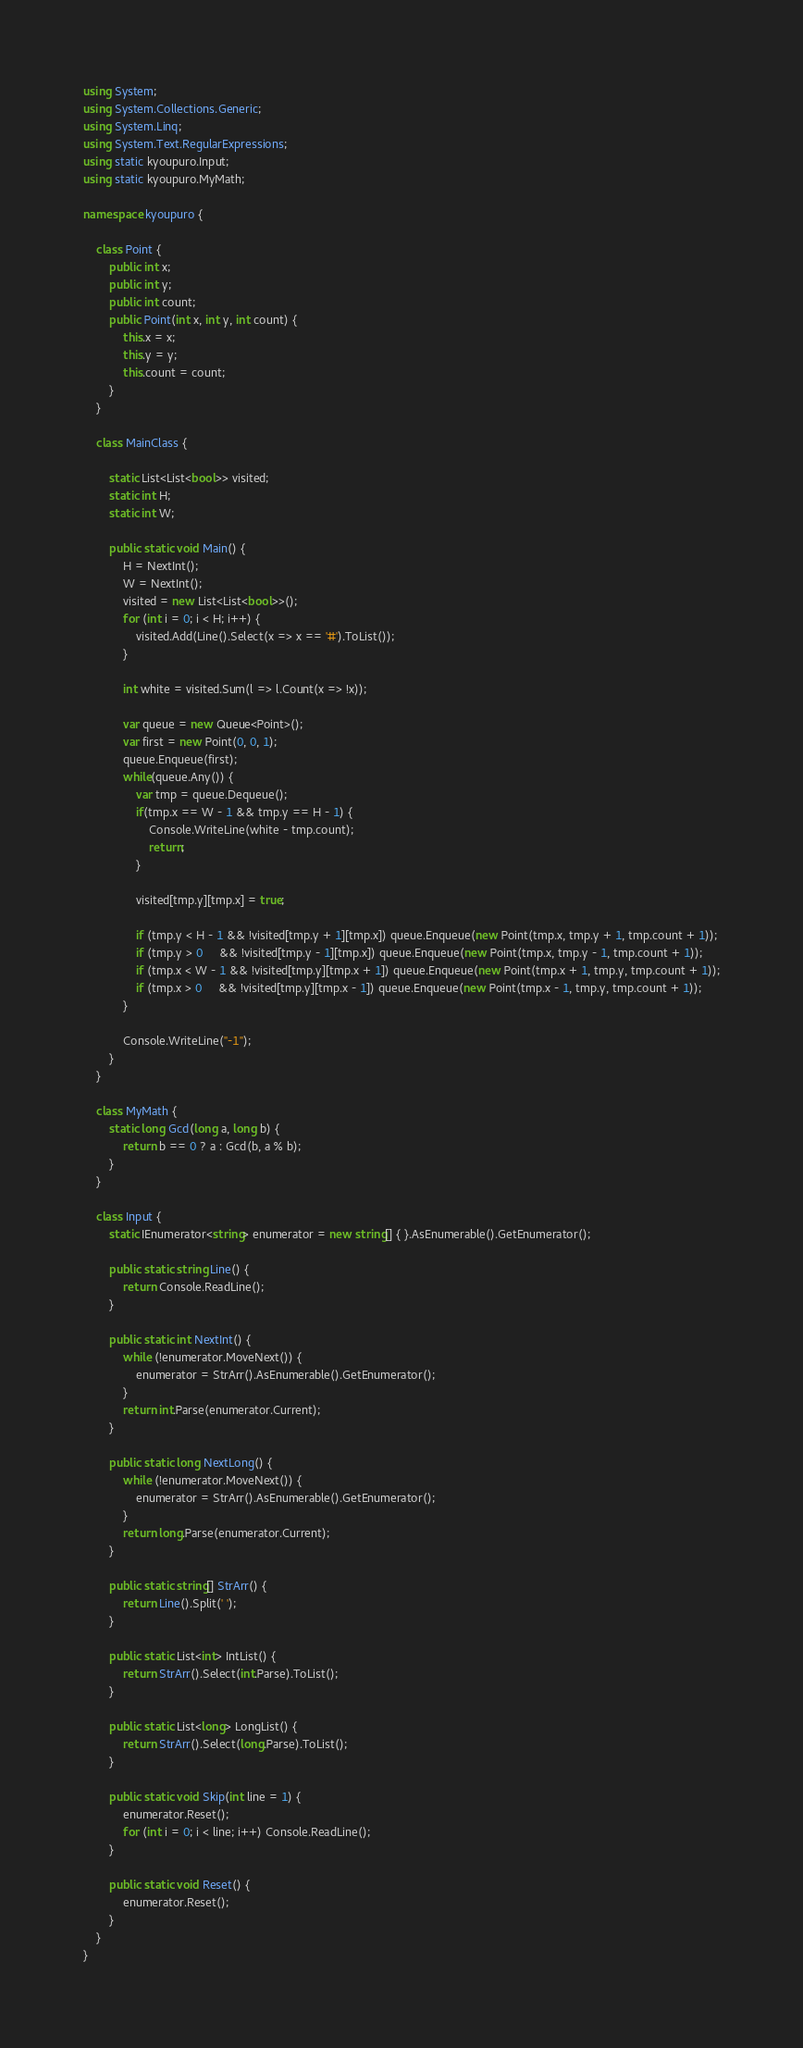<code> <loc_0><loc_0><loc_500><loc_500><_C#_>using System;
using System.Collections.Generic;
using System.Linq;
using System.Text.RegularExpressions;
using static kyoupuro.Input;
using static kyoupuro.MyMath;

namespace kyoupuro {

    class Point {
        public int x;
        public int y;
        public int count;
        public Point(int x, int y, int count) {
            this.x = x;
            this.y = y;
            this.count = count;
        }
    }

    class MainClass {

        static List<List<bool>> visited;
        static int H;
        static int W;

        public static void Main() {
            H = NextInt();
            W = NextInt();
            visited = new List<List<bool>>();
            for (int i = 0; i < H; i++) {
                visited.Add(Line().Select(x => x == '#').ToList());
            }

            int white = visited.Sum(l => l.Count(x => !x));

            var queue = new Queue<Point>();
            var first = new Point(0, 0, 1);
            queue.Enqueue(first);
            while(queue.Any()) {
                var tmp = queue.Dequeue();
                if(tmp.x == W - 1 && tmp.y == H - 1) {
                    Console.WriteLine(white - tmp.count);
                    return;
                }

                visited[tmp.y][tmp.x] = true;

                if (tmp.y < H - 1 && !visited[tmp.y + 1][tmp.x]) queue.Enqueue(new Point(tmp.x, tmp.y + 1, tmp.count + 1));
                if (tmp.y > 0     && !visited[tmp.y - 1][tmp.x]) queue.Enqueue(new Point(tmp.x, tmp.y - 1, tmp.count + 1));
                if (tmp.x < W - 1 && !visited[tmp.y][tmp.x + 1]) queue.Enqueue(new Point(tmp.x + 1, tmp.y, tmp.count + 1));
                if (tmp.x > 0     && !visited[tmp.y][tmp.x - 1]) queue.Enqueue(new Point(tmp.x - 1, tmp.y, tmp.count + 1));
            }

            Console.WriteLine("-1");
        }
    }

    class MyMath {
        static long Gcd(long a, long b) {
            return b == 0 ? a : Gcd(b, a % b);
        }
    }

    class Input {
        static IEnumerator<string> enumerator = new string[] { }.AsEnumerable().GetEnumerator();

        public static string Line() {
            return Console.ReadLine();
        }

        public static int NextInt() {
            while (!enumerator.MoveNext()) {
                enumerator = StrArr().AsEnumerable().GetEnumerator();
            }
            return int.Parse(enumerator.Current);
        }

        public static long NextLong() {
            while (!enumerator.MoveNext()) {
                enumerator = StrArr().AsEnumerable().GetEnumerator();
            }
            return long.Parse(enumerator.Current);
        }

        public static string[] StrArr() {
            return Line().Split(' ');
        }

        public static List<int> IntList() {
            return StrArr().Select(int.Parse).ToList();
        }

        public static List<long> LongList() {
            return StrArr().Select(long.Parse).ToList();
        }

        public static void Skip(int line = 1) {
            enumerator.Reset();
            for (int i = 0; i < line; i++) Console.ReadLine();
        }

        public static void Reset() {
            enumerator.Reset();
        }
    }
}</code> 